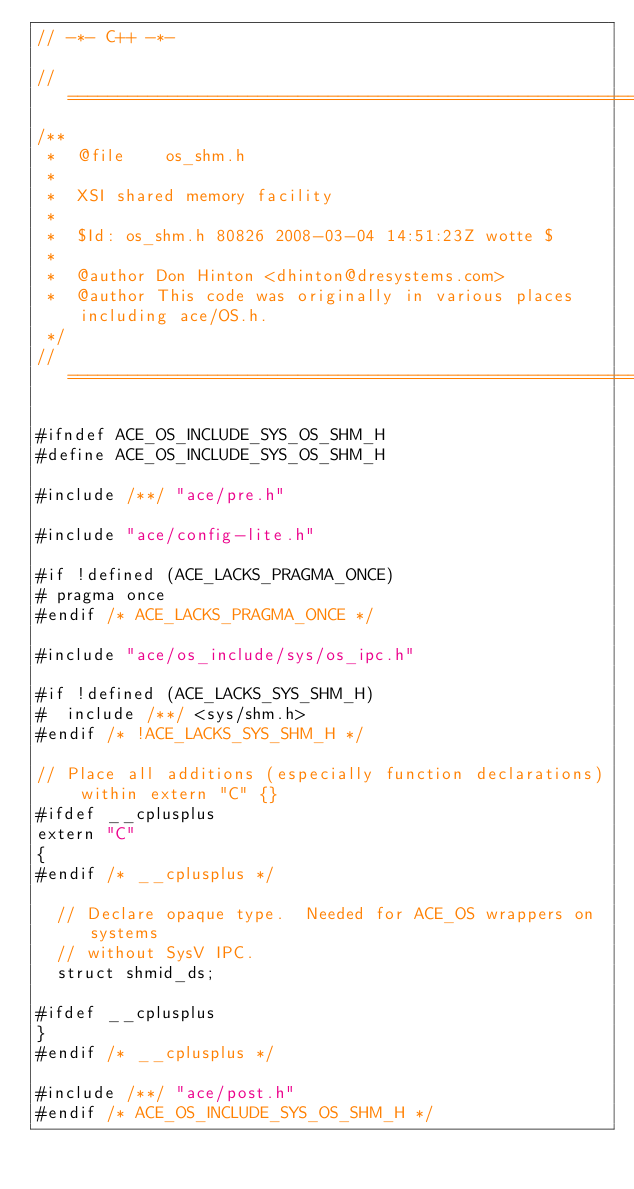Convert code to text. <code><loc_0><loc_0><loc_500><loc_500><_C_>// -*- C++ -*-

//=============================================================================
/**
 *  @file    os_shm.h
 *
 *  XSI shared memory facility
 *
 *  $Id: os_shm.h 80826 2008-03-04 14:51:23Z wotte $
 *
 *  @author Don Hinton <dhinton@dresystems.com>
 *  @author This code was originally in various places including ace/OS.h.
 */
//=============================================================================

#ifndef ACE_OS_INCLUDE_SYS_OS_SHM_H
#define ACE_OS_INCLUDE_SYS_OS_SHM_H

#include /**/ "ace/pre.h"

#include "ace/config-lite.h"

#if !defined (ACE_LACKS_PRAGMA_ONCE)
# pragma once
#endif /* ACE_LACKS_PRAGMA_ONCE */

#include "ace/os_include/sys/os_ipc.h"

#if !defined (ACE_LACKS_SYS_SHM_H)
#  include /**/ <sys/shm.h>
#endif /* !ACE_LACKS_SYS_SHM_H */

// Place all additions (especially function declarations) within extern "C" {}
#ifdef __cplusplus
extern "C"
{
#endif /* __cplusplus */

  // Declare opaque type.  Needed for ACE_OS wrappers on systems
  // without SysV IPC.
  struct shmid_ds;

#ifdef __cplusplus
}
#endif /* __cplusplus */

#include /**/ "ace/post.h"
#endif /* ACE_OS_INCLUDE_SYS_OS_SHM_H */
</code> 